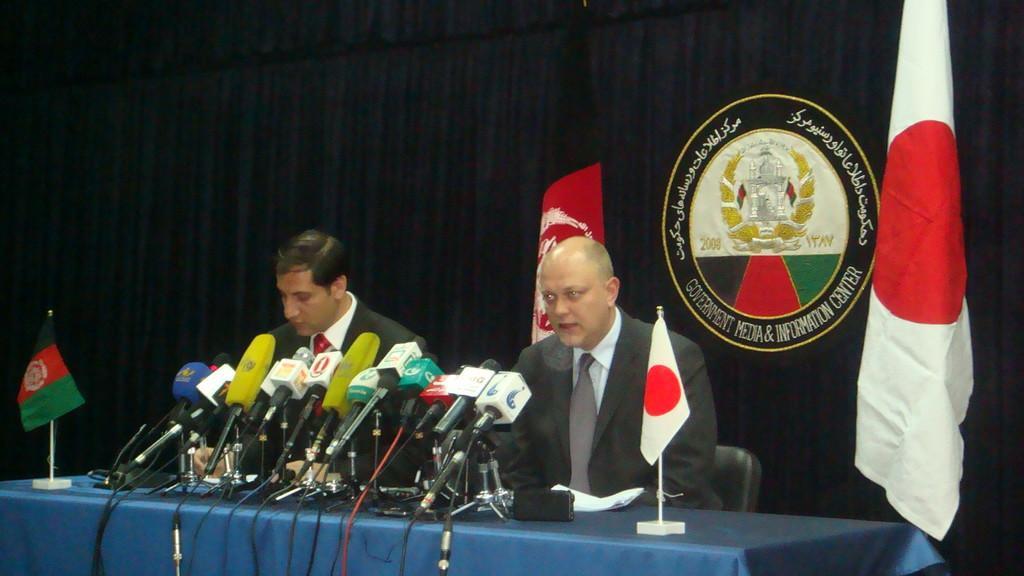Could you give a brief overview of what you see in this image? In this image I can see two men are sitting on chairs in front of a table. These men are wearing black color suits. On the table I can see flags, microphones and blue color covered on it. In the background I can see black color curtains and some logo on it. 